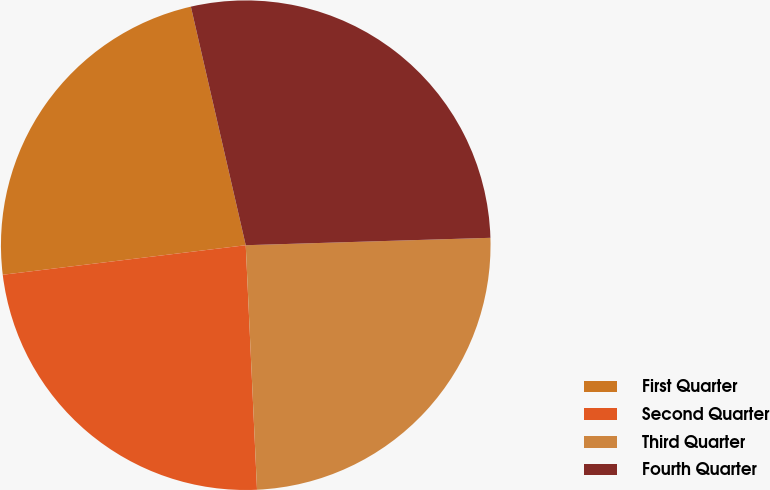Convert chart. <chart><loc_0><loc_0><loc_500><loc_500><pie_chart><fcel>First Quarter<fcel>Second Quarter<fcel>Third Quarter<fcel>Fourth Quarter<nl><fcel>23.33%<fcel>23.81%<fcel>24.75%<fcel>28.12%<nl></chart> 